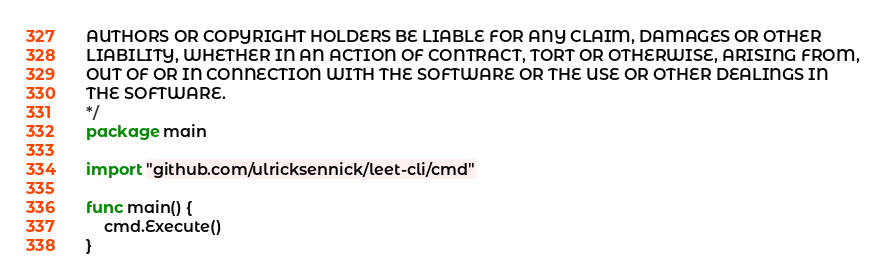Convert code to text. <code><loc_0><loc_0><loc_500><loc_500><_Go_>AUTHORS OR COPYRIGHT HOLDERS BE LIABLE FOR ANY CLAIM, DAMAGES OR OTHER
LIABILITY, WHETHER IN AN ACTION OF CONTRACT, TORT OR OTHERWISE, ARISING FROM,
OUT OF OR IN CONNECTION WITH THE SOFTWARE OR THE USE OR OTHER DEALINGS IN
THE SOFTWARE.
*/
package main

import "github.com/ulricksennick/leet-cli/cmd"

func main() {
	cmd.Execute()
}
</code> 